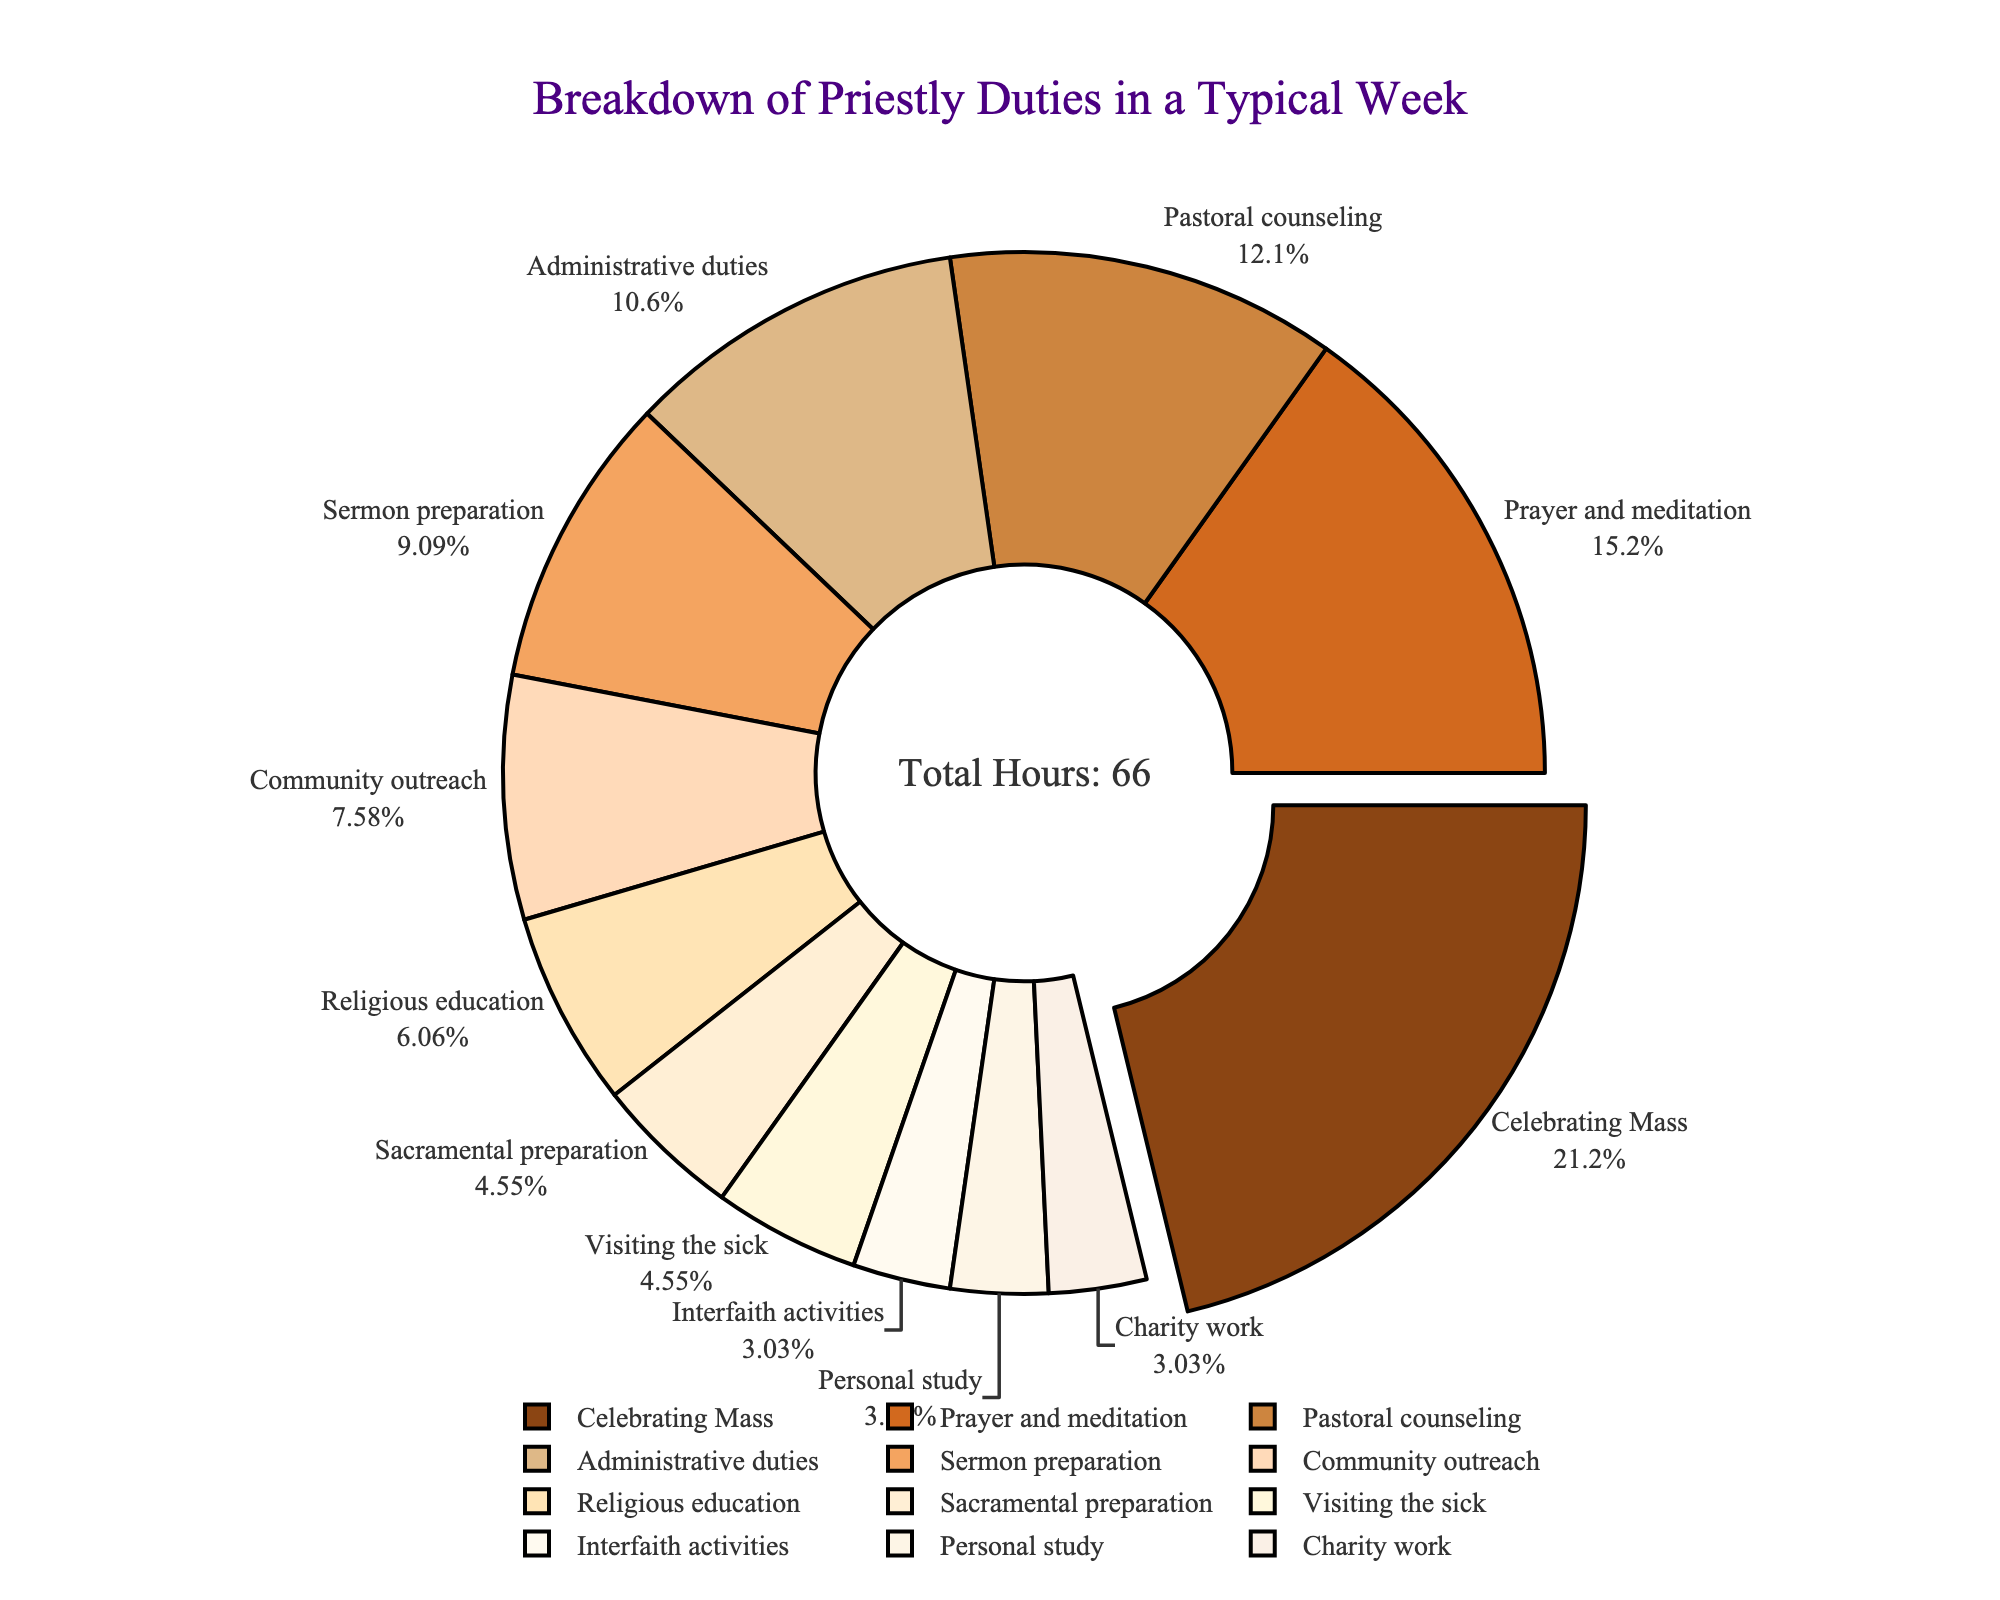What is the activity where the priest spends the most time? The largest section of the pie chart shows the activity where the priest spends the most time. In this case, it is "Celebrating Mass." Hence, the priest spends the most time on this activity.
Answer: Celebrating Mass What percentage of time is spent on pastoral counseling? The pie chart shows the percentages for each activity. The segment labeled "Pastoral counseling" indicates the percentage.
Answer: 12.7% How many total hours are spent on administrative duties and sermon preparation combined? To find the total, add the hours spent on administrative duties (7) and sermon preparation (6).
Answer: 13 Which activity consumes less time: community outreach or sacramental preparation? Locate the sections for "Community outreach" and "Sacramental preparation" on the pie chart. Compare the percentages.
Answer: Sacramental preparation What is the combined percentage of time spent on personal study, interfaith activities, and charity work? The percentages for personal study (2.8%), interfaith activities (2.8%), and charity work (2.8%) are shown on the pie chart. Adding these together gives the combined percentage.
Answer: 8.4% Which activity has a larger proportion of time: visiting the sick or religious education? By comparing the sections on the pie chart, one can see that "Religious education" has a larger proportion than "Visiting the sick."
Answer: Religious education What is the percentage difference between time spent on celebrating Mass and prayer and meditation? The percentage for celebrating Mass is 24.0% and for prayer and meditation is 17.1%. Subtracting these gives the difference.
Answer: 6.9% What is the relative proportion of time spent on administrative duties to community outreach? From the pie chart, administrative duties take 12.1% and community outreach takes 8.6%. Dividing these gives the relative proportion (12.1/8.6).
Answer: 1.41 Which is greater, the time spent on charity work or sacramental preparation? By comparing the pie chart sections, "Sacramental preparation" takes 5.1% and "Charity work" takes 2.8%.
Answer: Sacramental preparation What is the median number of hours spent on these priestly activities? To find the median, sort the hours (14, 10, 8, 7, 6, 5, 4, 3, 3, 2, 2, 2) and find the middle value(s). If there is an even number of data points, the median is the average of the two middle values (5 and 4).
Answer: 4.5 